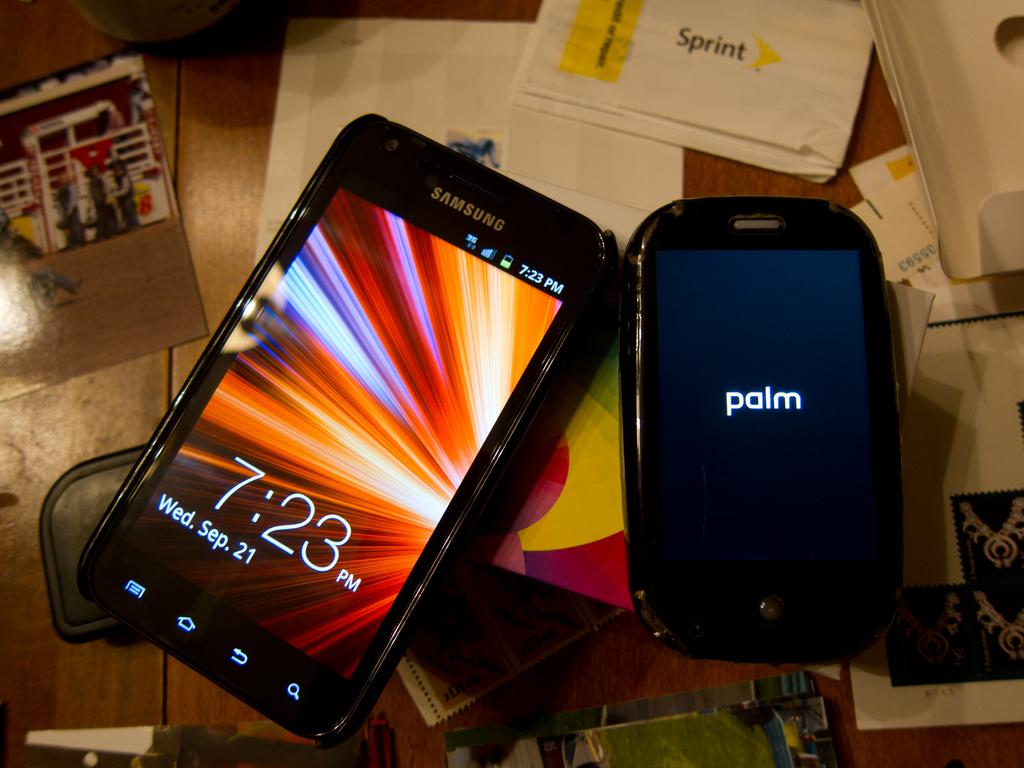<image>
Render a clear and concise summary of the photo. Palm cell phone next to a Samsung phone that has the time at 7:23. 